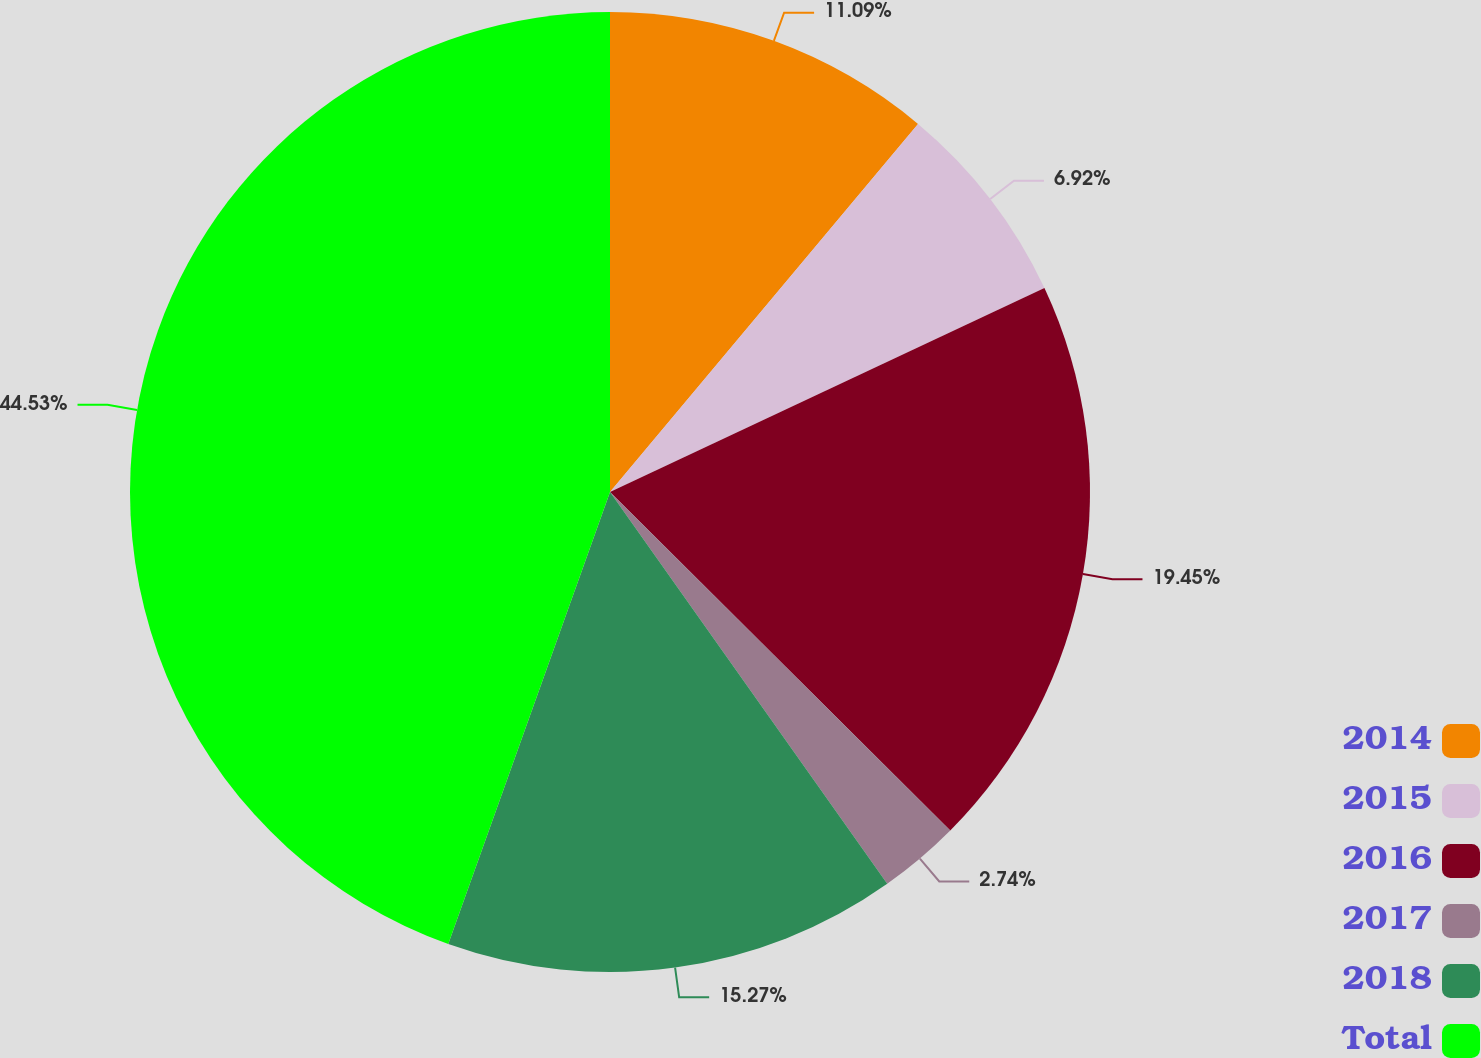Convert chart. <chart><loc_0><loc_0><loc_500><loc_500><pie_chart><fcel>2014<fcel>2015<fcel>2016<fcel>2017<fcel>2018<fcel>Total<nl><fcel>11.09%<fcel>6.92%<fcel>19.45%<fcel>2.74%<fcel>15.27%<fcel>44.53%<nl></chart> 